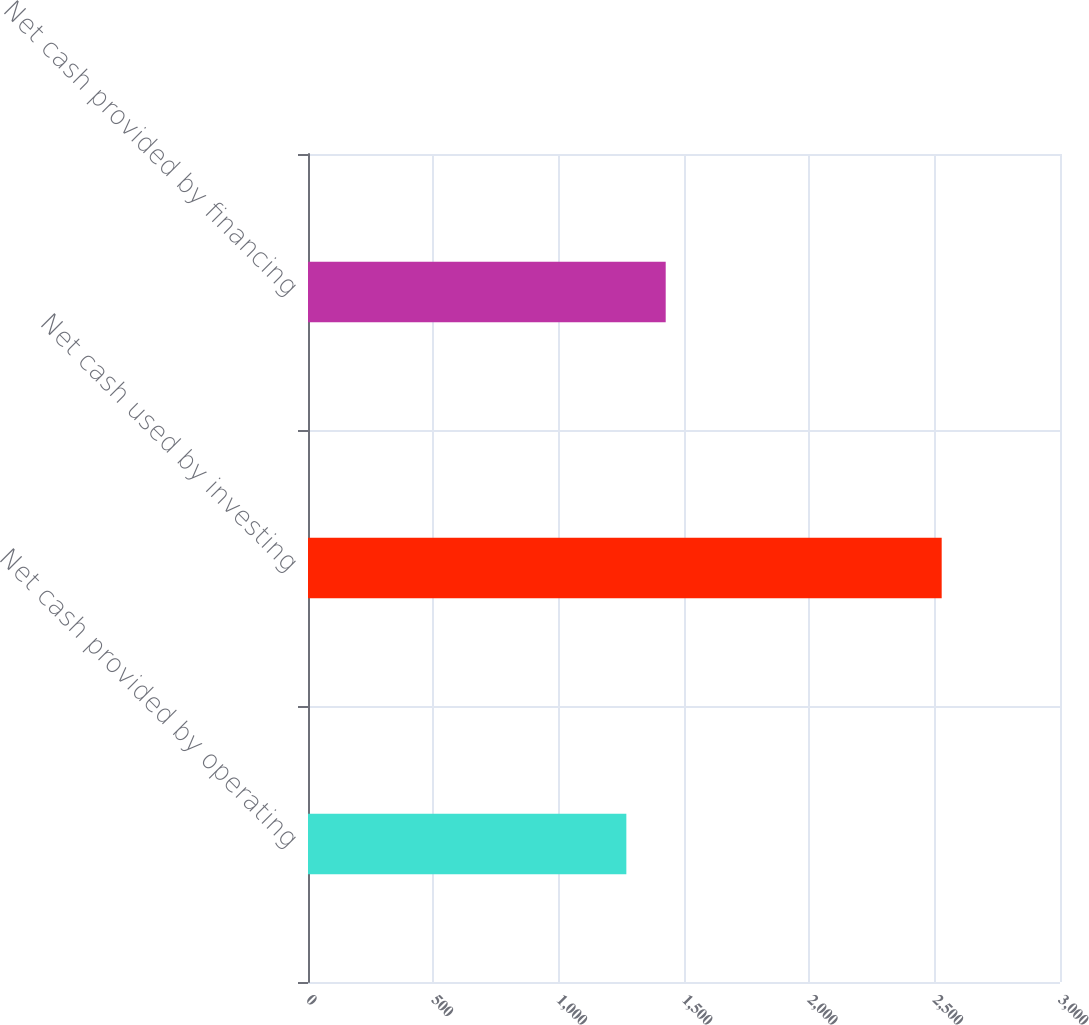Convert chart. <chart><loc_0><loc_0><loc_500><loc_500><bar_chart><fcel>Net cash provided by operating<fcel>Net cash used by investing<fcel>Net cash provided by financing<nl><fcel>1270<fcel>2528<fcel>1427<nl></chart> 